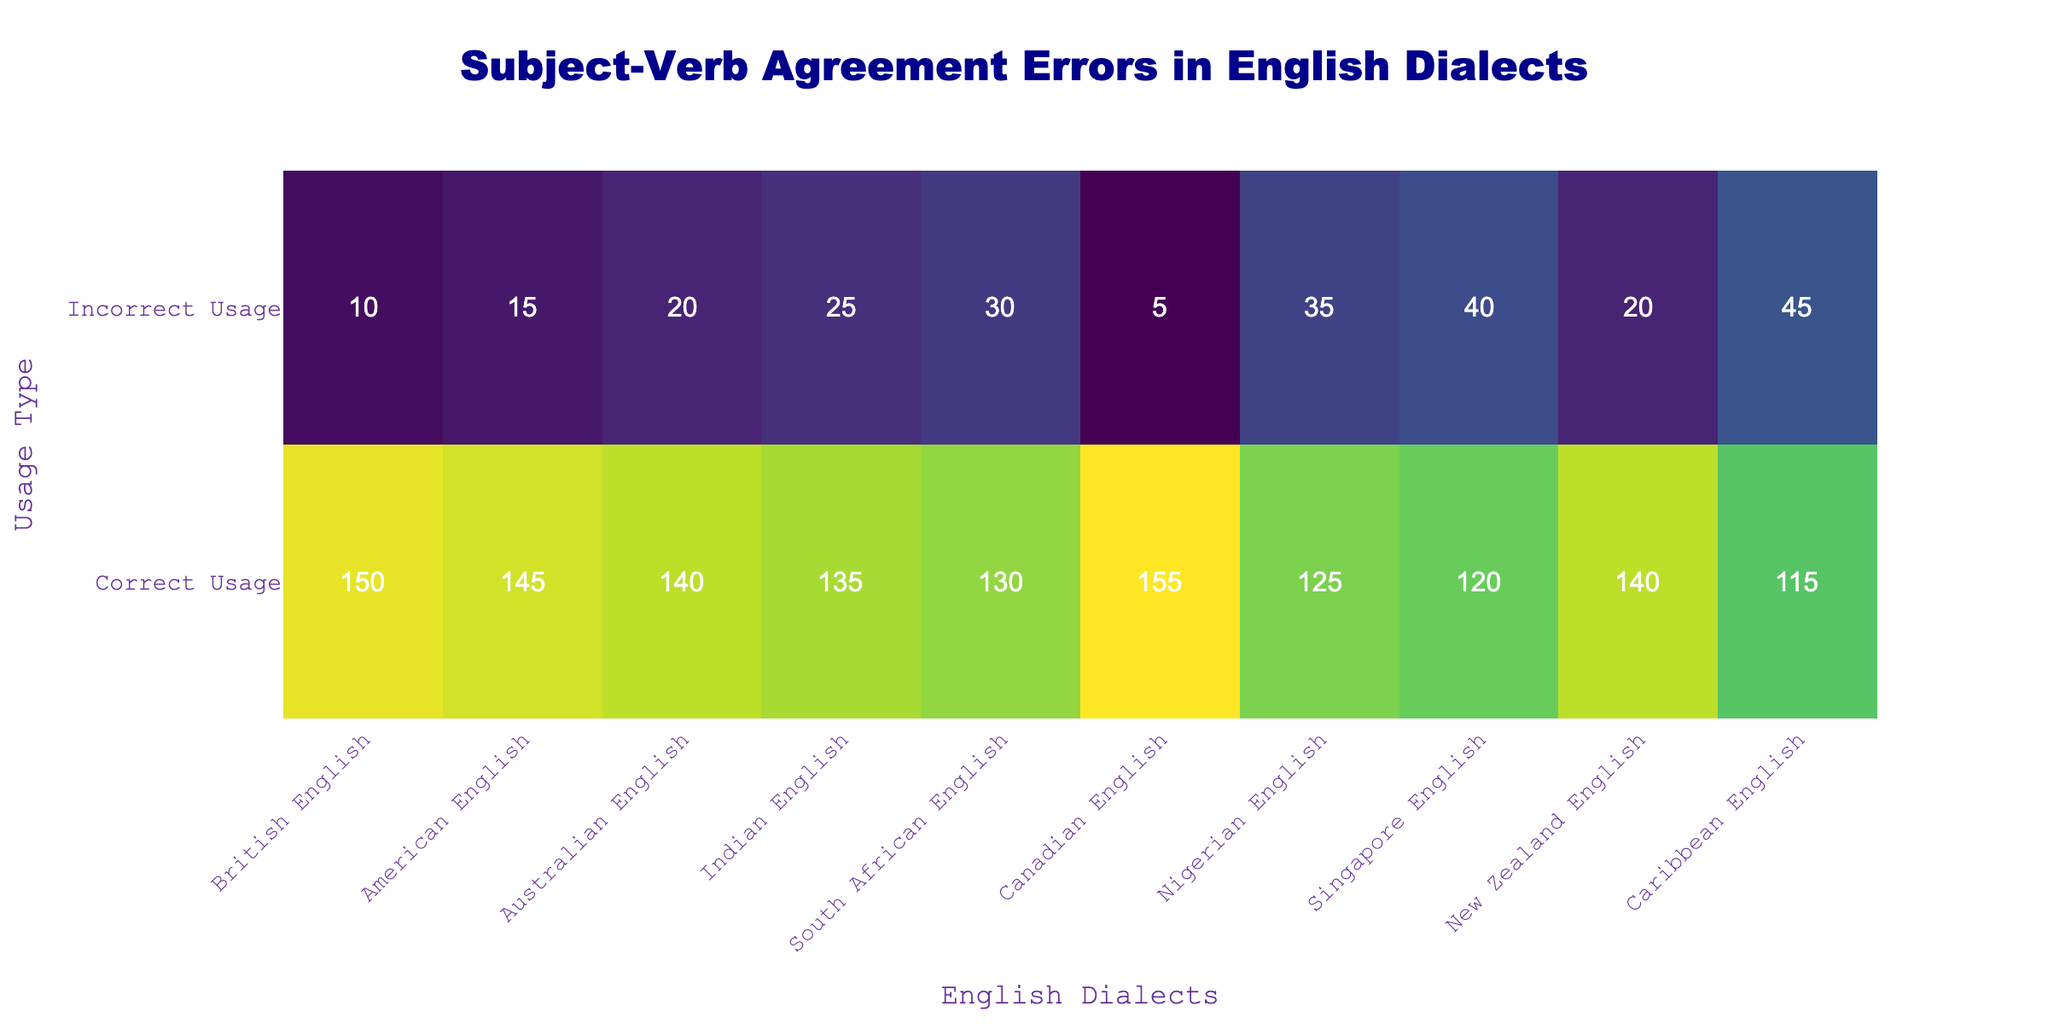What is the total number of correct usages for Canadian English? The table shows that for Canadian English, the number of correct usages is 155.
Answer: 155 Which dialect has the highest incorrect usage? By comparing the incorrect usage numbers, Caribbean English has the highest with 45, as highlighted in the table.
Answer: Caribbean English What is the difference in incorrect usage between Nigerian English and Singapore English? Nigerian English has 35 incorrect usages, while Singapore English has 40. The difference is calculated as 40 - 35 = 5.
Answer: 5 Is the number of incorrect usages in British English greater than in Australian English? British English has 10 incorrect usages and Australian English has 20. Since 10 is not greater than 20, the answer is no.
Answer: No What is the average number of correct usages across all dialects? To find the average, sum the correct usages: 150 + 145 + 140 + 135 + 130 + 155 + 125 + 120 + 140 + 115 = 1,525 and then divide by the number of dialects, which is 10. Therefore, 1,525 / 10 = 152.5.
Answer: 152.5 Which dialect has the lowest correct usage? Looking at the correct usage values, Nigerian English has the lowest with 125, as displayed in the table.
Answer: Nigerian English What percentage of Australian English usages are incorrect? Australian English has 20 incorrect usages out of a total of (140 correct + 20 incorrect) = 160 usages. The percentage is calculated as (20 / 160) * 100 = 12.5%.
Answer: 12.5% Which two dialects have the closest number of incorrect usages? By reviewing the incorrect usage values, American English has 15 and Indian English has 25. The closest difference is between British English (10) and American English (15), which is a difference of 5.
Answer: British English and American English How many more correct usages does Canadian English have compared to South African English? Canadian English has 155 correct usages while South African English has 130. The difference is 155 - 130 = 25.
Answer: 25 